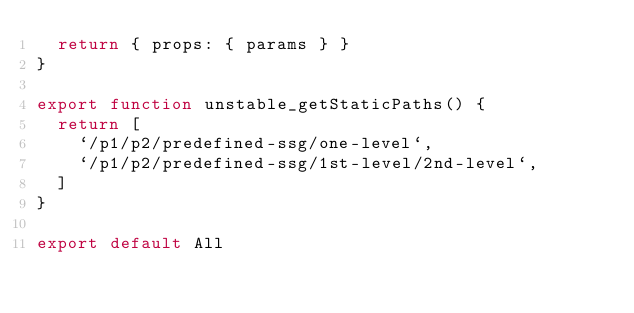Convert code to text. <code><loc_0><loc_0><loc_500><loc_500><_JavaScript_>  return { props: { params } }
}

export function unstable_getStaticPaths() {
  return [
    `/p1/p2/predefined-ssg/one-level`,
    `/p1/p2/predefined-ssg/1st-level/2nd-level`,
  ]
}

export default All
</code> 